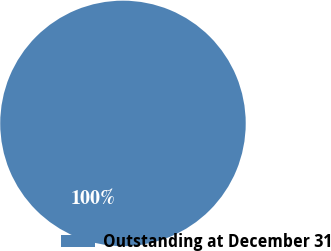Convert chart. <chart><loc_0><loc_0><loc_500><loc_500><pie_chart><fcel>Outstanding at December 31<nl><fcel>100.0%<nl></chart> 